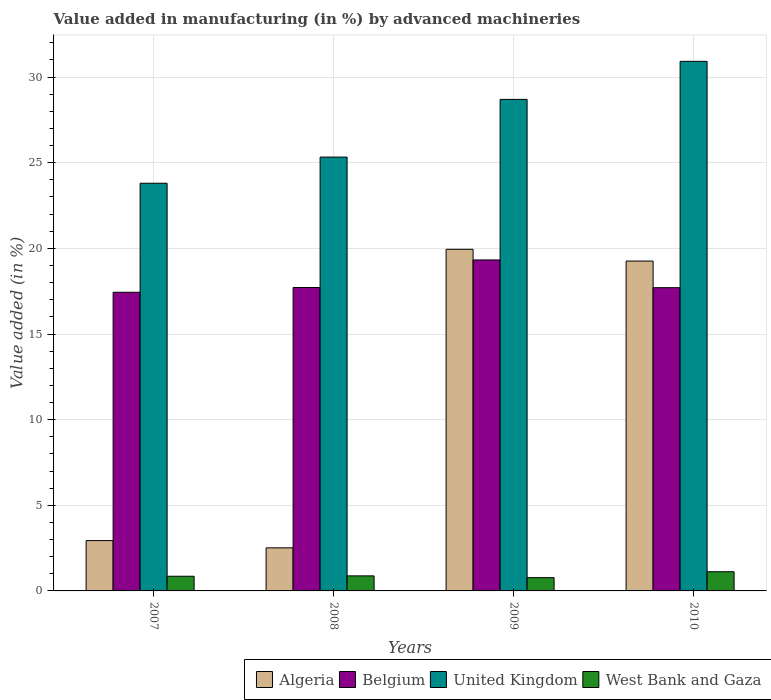How many groups of bars are there?
Provide a succinct answer. 4. Are the number of bars per tick equal to the number of legend labels?
Your answer should be compact. Yes. What is the label of the 1st group of bars from the left?
Provide a succinct answer. 2007. In how many cases, is the number of bars for a given year not equal to the number of legend labels?
Provide a short and direct response. 0. What is the percentage of value added in manufacturing by advanced machineries in Algeria in 2008?
Provide a succinct answer. 2.51. Across all years, what is the maximum percentage of value added in manufacturing by advanced machineries in Belgium?
Your answer should be very brief. 19.32. Across all years, what is the minimum percentage of value added in manufacturing by advanced machineries in United Kingdom?
Offer a very short reply. 23.8. In which year was the percentage of value added in manufacturing by advanced machineries in Belgium maximum?
Offer a terse response. 2009. What is the total percentage of value added in manufacturing by advanced machineries in United Kingdom in the graph?
Provide a succinct answer. 108.75. What is the difference between the percentage of value added in manufacturing by advanced machineries in West Bank and Gaza in 2009 and that in 2010?
Your answer should be very brief. -0.35. What is the difference between the percentage of value added in manufacturing by advanced machineries in Belgium in 2008 and the percentage of value added in manufacturing by advanced machineries in Algeria in 2009?
Ensure brevity in your answer.  -2.23. What is the average percentage of value added in manufacturing by advanced machineries in United Kingdom per year?
Provide a succinct answer. 27.19. In the year 2008, what is the difference between the percentage of value added in manufacturing by advanced machineries in United Kingdom and percentage of value added in manufacturing by advanced machineries in Algeria?
Offer a very short reply. 22.81. In how many years, is the percentage of value added in manufacturing by advanced machineries in West Bank and Gaza greater than 4 %?
Provide a succinct answer. 0. What is the ratio of the percentage of value added in manufacturing by advanced machineries in West Bank and Gaza in 2007 to that in 2009?
Give a very brief answer. 1.11. Is the percentage of value added in manufacturing by advanced machineries in United Kingdom in 2007 less than that in 2009?
Provide a succinct answer. Yes. What is the difference between the highest and the second highest percentage of value added in manufacturing by advanced machineries in United Kingdom?
Offer a terse response. 2.22. What is the difference between the highest and the lowest percentage of value added in manufacturing by advanced machineries in Algeria?
Offer a terse response. 17.43. In how many years, is the percentage of value added in manufacturing by advanced machineries in Belgium greater than the average percentage of value added in manufacturing by advanced machineries in Belgium taken over all years?
Your response must be concise. 1. Is the sum of the percentage of value added in manufacturing by advanced machineries in Algeria in 2007 and 2008 greater than the maximum percentage of value added in manufacturing by advanced machineries in West Bank and Gaza across all years?
Keep it short and to the point. Yes. What does the 4th bar from the left in 2007 represents?
Keep it short and to the point. West Bank and Gaza. Is it the case that in every year, the sum of the percentage of value added in manufacturing by advanced machineries in United Kingdom and percentage of value added in manufacturing by advanced machineries in Algeria is greater than the percentage of value added in manufacturing by advanced machineries in Belgium?
Give a very brief answer. Yes. Are all the bars in the graph horizontal?
Make the answer very short. No. How many years are there in the graph?
Keep it short and to the point. 4. What is the difference between two consecutive major ticks on the Y-axis?
Provide a succinct answer. 5. Are the values on the major ticks of Y-axis written in scientific E-notation?
Provide a short and direct response. No. Where does the legend appear in the graph?
Make the answer very short. Bottom right. What is the title of the graph?
Offer a terse response. Value added in manufacturing (in %) by advanced machineries. What is the label or title of the Y-axis?
Provide a short and direct response. Value added (in %). What is the Value added (in %) in Algeria in 2007?
Your response must be concise. 2.94. What is the Value added (in %) in Belgium in 2007?
Give a very brief answer. 17.44. What is the Value added (in %) of United Kingdom in 2007?
Offer a terse response. 23.8. What is the Value added (in %) in West Bank and Gaza in 2007?
Keep it short and to the point. 0.86. What is the Value added (in %) in Algeria in 2008?
Offer a very short reply. 2.51. What is the Value added (in %) in Belgium in 2008?
Provide a succinct answer. 17.72. What is the Value added (in %) of United Kingdom in 2008?
Provide a succinct answer. 25.33. What is the Value added (in %) in West Bank and Gaza in 2008?
Provide a succinct answer. 0.88. What is the Value added (in %) of Algeria in 2009?
Offer a terse response. 19.95. What is the Value added (in %) in Belgium in 2009?
Keep it short and to the point. 19.32. What is the Value added (in %) in United Kingdom in 2009?
Your answer should be very brief. 28.7. What is the Value added (in %) of West Bank and Gaza in 2009?
Offer a very short reply. 0.77. What is the Value added (in %) of Algeria in 2010?
Your answer should be compact. 19.26. What is the Value added (in %) of Belgium in 2010?
Offer a very short reply. 17.71. What is the Value added (in %) in United Kingdom in 2010?
Ensure brevity in your answer.  30.92. What is the Value added (in %) of West Bank and Gaza in 2010?
Your answer should be very brief. 1.12. Across all years, what is the maximum Value added (in %) of Algeria?
Your answer should be very brief. 19.95. Across all years, what is the maximum Value added (in %) in Belgium?
Make the answer very short. 19.32. Across all years, what is the maximum Value added (in %) in United Kingdom?
Ensure brevity in your answer.  30.92. Across all years, what is the maximum Value added (in %) in West Bank and Gaza?
Offer a very short reply. 1.12. Across all years, what is the minimum Value added (in %) in Algeria?
Your response must be concise. 2.51. Across all years, what is the minimum Value added (in %) of Belgium?
Your answer should be compact. 17.44. Across all years, what is the minimum Value added (in %) in United Kingdom?
Offer a very short reply. 23.8. Across all years, what is the minimum Value added (in %) of West Bank and Gaza?
Provide a succinct answer. 0.77. What is the total Value added (in %) of Algeria in the graph?
Make the answer very short. 44.66. What is the total Value added (in %) in Belgium in the graph?
Offer a very short reply. 72.18. What is the total Value added (in %) in United Kingdom in the graph?
Offer a very short reply. 108.75. What is the total Value added (in %) of West Bank and Gaza in the graph?
Keep it short and to the point. 3.63. What is the difference between the Value added (in %) in Algeria in 2007 and that in 2008?
Your answer should be very brief. 0.42. What is the difference between the Value added (in %) of Belgium in 2007 and that in 2008?
Offer a terse response. -0.28. What is the difference between the Value added (in %) of United Kingdom in 2007 and that in 2008?
Provide a succinct answer. -1.53. What is the difference between the Value added (in %) of West Bank and Gaza in 2007 and that in 2008?
Keep it short and to the point. -0.02. What is the difference between the Value added (in %) of Algeria in 2007 and that in 2009?
Provide a short and direct response. -17.01. What is the difference between the Value added (in %) of Belgium in 2007 and that in 2009?
Your response must be concise. -1.89. What is the difference between the Value added (in %) in United Kingdom in 2007 and that in 2009?
Your answer should be compact. -4.9. What is the difference between the Value added (in %) in West Bank and Gaza in 2007 and that in 2009?
Give a very brief answer. 0.08. What is the difference between the Value added (in %) of Algeria in 2007 and that in 2010?
Offer a terse response. -16.32. What is the difference between the Value added (in %) in Belgium in 2007 and that in 2010?
Keep it short and to the point. -0.27. What is the difference between the Value added (in %) in United Kingdom in 2007 and that in 2010?
Offer a terse response. -7.12. What is the difference between the Value added (in %) of West Bank and Gaza in 2007 and that in 2010?
Offer a very short reply. -0.26. What is the difference between the Value added (in %) of Algeria in 2008 and that in 2009?
Your answer should be compact. -17.43. What is the difference between the Value added (in %) of Belgium in 2008 and that in 2009?
Your answer should be very brief. -1.61. What is the difference between the Value added (in %) in United Kingdom in 2008 and that in 2009?
Your answer should be compact. -3.37. What is the difference between the Value added (in %) in West Bank and Gaza in 2008 and that in 2009?
Keep it short and to the point. 0.1. What is the difference between the Value added (in %) of Algeria in 2008 and that in 2010?
Your response must be concise. -16.74. What is the difference between the Value added (in %) in Belgium in 2008 and that in 2010?
Provide a short and direct response. 0.01. What is the difference between the Value added (in %) in United Kingdom in 2008 and that in 2010?
Your response must be concise. -5.59. What is the difference between the Value added (in %) of West Bank and Gaza in 2008 and that in 2010?
Provide a succinct answer. -0.24. What is the difference between the Value added (in %) in Algeria in 2009 and that in 2010?
Make the answer very short. 0.69. What is the difference between the Value added (in %) of Belgium in 2009 and that in 2010?
Your answer should be very brief. 1.62. What is the difference between the Value added (in %) of United Kingdom in 2009 and that in 2010?
Your response must be concise. -2.22. What is the difference between the Value added (in %) of West Bank and Gaza in 2009 and that in 2010?
Keep it short and to the point. -0.35. What is the difference between the Value added (in %) of Algeria in 2007 and the Value added (in %) of Belgium in 2008?
Offer a terse response. -14.78. What is the difference between the Value added (in %) of Algeria in 2007 and the Value added (in %) of United Kingdom in 2008?
Give a very brief answer. -22.39. What is the difference between the Value added (in %) in Algeria in 2007 and the Value added (in %) in West Bank and Gaza in 2008?
Ensure brevity in your answer.  2.06. What is the difference between the Value added (in %) of Belgium in 2007 and the Value added (in %) of United Kingdom in 2008?
Your answer should be compact. -7.89. What is the difference between the Value added (in %) of Belgium in 2007 and the Value added (in %) of West Bank and Gaza in 2008?
Give a very brief answer. 16.56. What is the difference between the Value added (in %) of United Kingdom in 2007 and the Value added (in %) of West Bank and Gaza in 2008?
Your answer should be very brief. 22.92. What is the difference between the Value added (in %) of Algeria in 2007 and the Value added (in %) of Belgium in 2009?
Your answer should be compact. -16.39. What is the difference between the Value added (in %) in Algeria in 2007 and the Value added (in %) in United Kingdom in 2009?
Make the answer very short. -25.76. What is the difference between the Value added (in %) of Algeria in 2007 and the Value added (in %) of West Bank and Gaza in 2009?
Make the answer very short. 2.16. What is the difference between the Value added (in %) of Belgium in 2007 and the Value added (in %) of United Kingdom in 2009?
Offer a very short reply. -11.26. What is the difference between the Value added (in %) in Belgium in 2007 and the Value added (in %) in West Bank and Gaza in 2009?
Keep it short and to the point. 16.66. What is the difference between the Value added (in %) in United Kingdom in 2007 and the Value added (in %) in West Bank and Gaza in 2009?
Provide a short and direct response. 23.03. What is the difference between the Value added (in %) of Algeria in 2007 and the Value added (in %) of Belgium in 2010?
Your answer should be compact. -14.77. What is the difference between the Value added (in %) of Algeria in 2007 and the Value added (in %) of United Kingdom in 2010?
Ensure brevity in your answer.  -27.98. What is the difference between the Value added (in %) of Algeria in 2007 and the Value added (in %) of West Bank and Gaza in 2010?
Your response must be concise. 1.82. What is the difference between the Value added (in %) of Belgium in 2007 and the Value added (in %) of United Kingdom in 2010?
Your response must be concise. -13.48. What is the difference between the Value added (in %) in Belgium in 2007 and the Value added (in %) in West Bank and Gaza in 2010?
Ensure brevity in your answer.  16.32. What is the difference between the Value added (in %) of United Kingdom in 2007 and the Value added (in %) of West Bank and Gaza in 2010?
Your answer should be compact. 22.68. What is the difference between the Value added (in %) of Algeria in 2008 and the Value added (in %) of Belgium in 2009?
Keep it short and to the point. -16.81. What is the difference between the Value added (in %) in Algeria in 2008 and the Value added (in %) in United Kingdom in 2009?
Give a very brief answer. -26.18. What is the difference between the Value added (in %) of Algeria in 2008 and the Value added (in %) of West Bank and Gaza in 2009?
Make the answer very short. 1.74. What is the difference between the Value added (in %) in Belgium in 2008 and the Value added (in %) in United Kingdom in 2009?
Your answer should be compact. -10.98. What is the difference between the Value added (in %) of Belgium in 2008 and the Value added (in %) of West Bank and Gaza in 2009?
Offer a terse response. 16.94. What is the difference between the Value added (in %) of United Kingdom in 2008 and the Value added (in %) of West Bank and Gaza in 2009?
Ensure brevity in your answer.  24.56. What is the difference between the Value added (in %) in Algeria in 2008 and the Value added (in %) in Belgium in 2010?
Provide a short and direct response. -15.19. What is the difference between the Value added (in %) in Algeria in 2008 and the Value added (in %) in United Kingdom in 2010?
Your response must be concise. -28.4. What is the difference between the Value added (in %) in Algeria in 2008 and the Value added (in %) in West Bank and Gaza in 2010?
Your answer should be very brief. 1.39. What is the difference between the Value added (in %) in Belgium in 2008 and the Value added (in %) in United Kingdom in 2010?
Ensure brevity in your answer.  -13.2. What is the difference between the Value added (in %) of Belgium in 2008 and the Value added (in %) of West Bank and Gaza in 2010?
Offer a terse response. 16.59. What is the difference between the Value added (in %) of United Kingdom in 2008 and the Value added (in %) of West Bank and Gaza in 2010?
Provide a succinct answer. 24.21. What is the difference between the Value added (in %) in Algeria in 2009 and the Value added (in %) in Belgium in 2010?
Offer a very short reply. 2.24. What is the difference between the Value added (in %) in Algeria in 2009 and the Value added (in %) in United Kingdom in 2010?
Provide a short and direct response. -10.97. What is the difference between the Value added (in %) of Algeria in 2009 and the Value added (in %) of West Bank and Gaza in 2010?
Give a very brief answer. 18.83. What is the difference between the Value added (in %) of Belgium in 2009 and the Value added (in %) of United Kingdom in 2010?
Your answer should be very brief. -11.59. What is the difference between the Value added (in %) in Belgium in 2009 and the Value added (in %) in West Bank and Gaza in 2010?
Offer a terse response. 18.2. What is the difference between the Value added (in %) of United Kingdom in 2009 and the Value added (in %) of West Bank and Gaza in 2010?
Offer a very short reply. 27.58. What is the average Value added (in %) in Algeria per year?
Provide a succinct answer. 11.16. What is the average Value added (in %) in Belgium per year?
Your answer should be compact. 18.05. What is the average Value added (in %) of United Kingdom per year?
Provide a short and direct response. 27.19. What is the average Value added (in %) of West Bank and Gaza per year?
Keep it short and to the point. 0.91. In the year 2007, what is the difference between the Value added (in %) of Algeria and Value added (in %) of Belgium?
Provide a succinct answer. -14.5. In the year 2007, what is the difference between the Value added (in %) of Algeria and Value added (in %) of United Kingdom?
Offer a very short reply. -20.86. In the year 2007, what is the difference between the Value added (in %) in Algeria and Value added (in %) in West Bank and Gaza?
Your answer should be very brief. 2.08. In the year 2007, what is the difference between the Value added (in %) in Belgium and Value added (in %) in United Kingdom?
Your response must be concise. -6.36. In the year 2007, what is the difference between the Value added (in %) in Belgium and Value added (in %) in West Bank and Gaza?
Your response must be concise. 16.58. In the year 2007, what is the difference between the Value added (in %) in United Kingdom and Value added (in %) in West Bank and Gaza?
Provide a short and direct response. 22.95. In the year 2008, what is the difference between the Value added (in %) in Algeria and Value added (in %) in Belgium?
Your response must be concise. -15.2. In the year 2008, what is the difference between the Value added (in %) in Algeria and Value added (in %) in United Kingdom?
Offer a very short reply. -22.81. In the year 2008, what is the difference between the Value added (in %) of Algeria and Value added (in %) of West Bank and Gaza?
Provide a succinct answer. 1.64. In the year 2008, what is the difference between the Value added (in %) in Belgium and Value added (in %) in United Kingdom?
Offer a terse response. -7.61. In the year 2008, what is the difference between the Value added (in %) of Belgium and Value added (in %) of West Bank and Gaza?
Your answer should be compact. 16.84. In the year 2008, what is the difference between the Value added (in %) in United Kingdom and Value added (in %) in West Bank and Gaza?
Keep it short and to the point. 24.45. In the year 2009, what is the difference between the Value added (in %) in Algeria and Value added (in %) in Belgium?
Your answer should be very brief. 0.62. In the year 2009, what is the difference between the Value added (in %) in Algeria and Value added (in %) in United Kingdom?
Make the answer very short. -8.75. In the year 2009, what is the difference between the Value added (in %) of Algeria and Value added (in %) of West Bank and Gaza?
Your answer should be compact. 19.17. In the year 2009, what is the difference between the Value added (in %) in Belgium and Value added (in %) in United Kingdom?
Ensure brevity in your answer.  -9.37. In the year 2009, what is the difference between the Value added (in %) of Belgium and Value added (in %) of West Bank and Gaza?
Your answer should be very brief. 18.55. In the year 2009, what is the difference between the Value added (in %) in United Kingdom and Value added (in %) in West Bank and Gaza?
Your answer should be very brief. 27.92. In the year 2010, what is the difference between the Value added (in %) in Algeria and Value added (in %) in Belgium?
Your response must be concise. 1.55. In the year 2010, what is the difference between the Value added (in %) in Algeria and Value added (in %) in United Kingdom?
Provide a succinct answer. -11.66. In the year 2010, what is the difference between the Value added (in %) in Algeria and Value added (in %) in West Bank and Gaza?
Offer a very short reply. 18.14. In the year 2010, what is the difference between the Value added (in %) of Belgium and Value added (in %) of United Kingdom?
Make the answer very short. -13.21. In the year 2010, what is the difference between the Value added (in %) of Belgium and Value added (in %) of West Bank and Gaza?
Provide a short and direct response. 16.58. In the year 2010, what is the difference between the Value added (in %) in United Kingdom and Value added (in %) in West Bank and Gaza?
Make the answer very short. 29.8. What is the ratio of the Value added (in %) in Algeria in 2007 to that in 2008?
Provide a succinct answer. 1.17. What is the ratio of the Value added (in %) in Belgium in 2007 to that in 2008?
Ensure brevity in your answer.  0.98. What is the ratio of the Value added (in %) in United Kingdom in 2007 to that in 2008?
Give a very brief answer. 0.94. What is the ratio of the Value added (in %) of West Bank and Gaza in 2007 to that in 2008?
Provide a succinct answer. 0.98. What is the ratio of the Value added (in %) of Algeria in 2007 to that in 2009?
Offer a very short reply. 0.15. What is the ratio of the Value added (in %) of Belgium in 2007 to that in 2009?
Your answer should be compact. 0.9. What is the ratio of the Value added (in %) of United Kingdom in 2007 to that in 2009?
Give a very brief answer. 0.83. What is the ratio of the Value added (in %) of West Bank and Gaza in 2007 to that in 2009?
Provide a short and direct response. 1.11. What is the ratio of the Value added (in %) of Algeria in 2007 to that in 2010?
Your answer should be compact. 0.15. What is the ratio of the Value added (in %) in Belgium in 2007 to that in 2010?
Your answer should be compact. 0.98. What is the ratio of the Value added (in %) of United Kingdom in 2007 to that in 2010?
Your response must be concise. 0.77. What is the ratio of the Value added (in %) in West Bank and Gaza in 2007 to that in 2010?
Offer a very short reply. 0.77. What is the ratio of the Value added (in %) of Algeria in 2008 to that in 2009?
Make the answer very short. 0.13. What is the ratio of the Value added (in %) of United Kingdom in 2008 to that in 2009?
Ensure brevity in your answer.  0.88. What is the ratio of the Value added (in %) in West Bank and Gaza in 2008 to that in 2009?
Your response must be concise. 1.13. What is the ratio of the Value added (in %) of Algeria in 2008 to that in 2010?
Provide a succinct answer. 0.13. What is the ratio of the Value added (in %) of Belgium in 2008 to that in 2010?
Your response must be concise. 1. What is the ratio of the Value added (in %) of United Kingdom in 2008 to that in 2010?
Your answer should be compact. 0.82. What is the ratio of the Value added (in %) of West Bank and Gaza in 2008 to that in 2010?
Provide a short and direct response. 0.78. What is the ratio of the Value added (in %) of Algeria in 2009 to that in 2010?
Offer a terse response. 1.04. What is the ratio of the Value added (in %) in Belgium in 2009 to that in 2010?
Make the answer very short. 1.09. What is the ratio of the Value added (in %) of United Kingdom in 2009 to that in 2010?
Give a very brief answer. 0.93. What is the ratio of the Value added (in %) in West Bank and Gaza in 2009 to that in 2010?
Your answer should be very brief. 0.69. What is the difference between the highest and the second highest Value added (in %) of Algeria?
Keep it short and to the point. 0.69. What is the difference between the highest and the second highest Value added (in %) in Belgium?
Offer a very short reply. 1.61. What is the difference between the highest and the second highest Value added (in %) in United Kingdom?
Your answer should be very brief. 2.22. What is the difference between the highest and the second highest Value added (in %) of West Bank and Gaza?
Offer a very short reply. 0.24. What is the difference between the highest and the lowest Value added (in %) in Algeria?
Your answer should be very brief. 17.43. What is the difference between the highest and the lowest Value added (in %) in Belgium?
Provide a short and direct response. 1.89. What is the difference between the highest and the lowest Value added (in %) in United Kingdom?
Offer a terse response. 7.12. What is the difference between the highest and the lowest Value added (in %) in West Bank and Gaza?
Offer a very short reply. 0.35. 